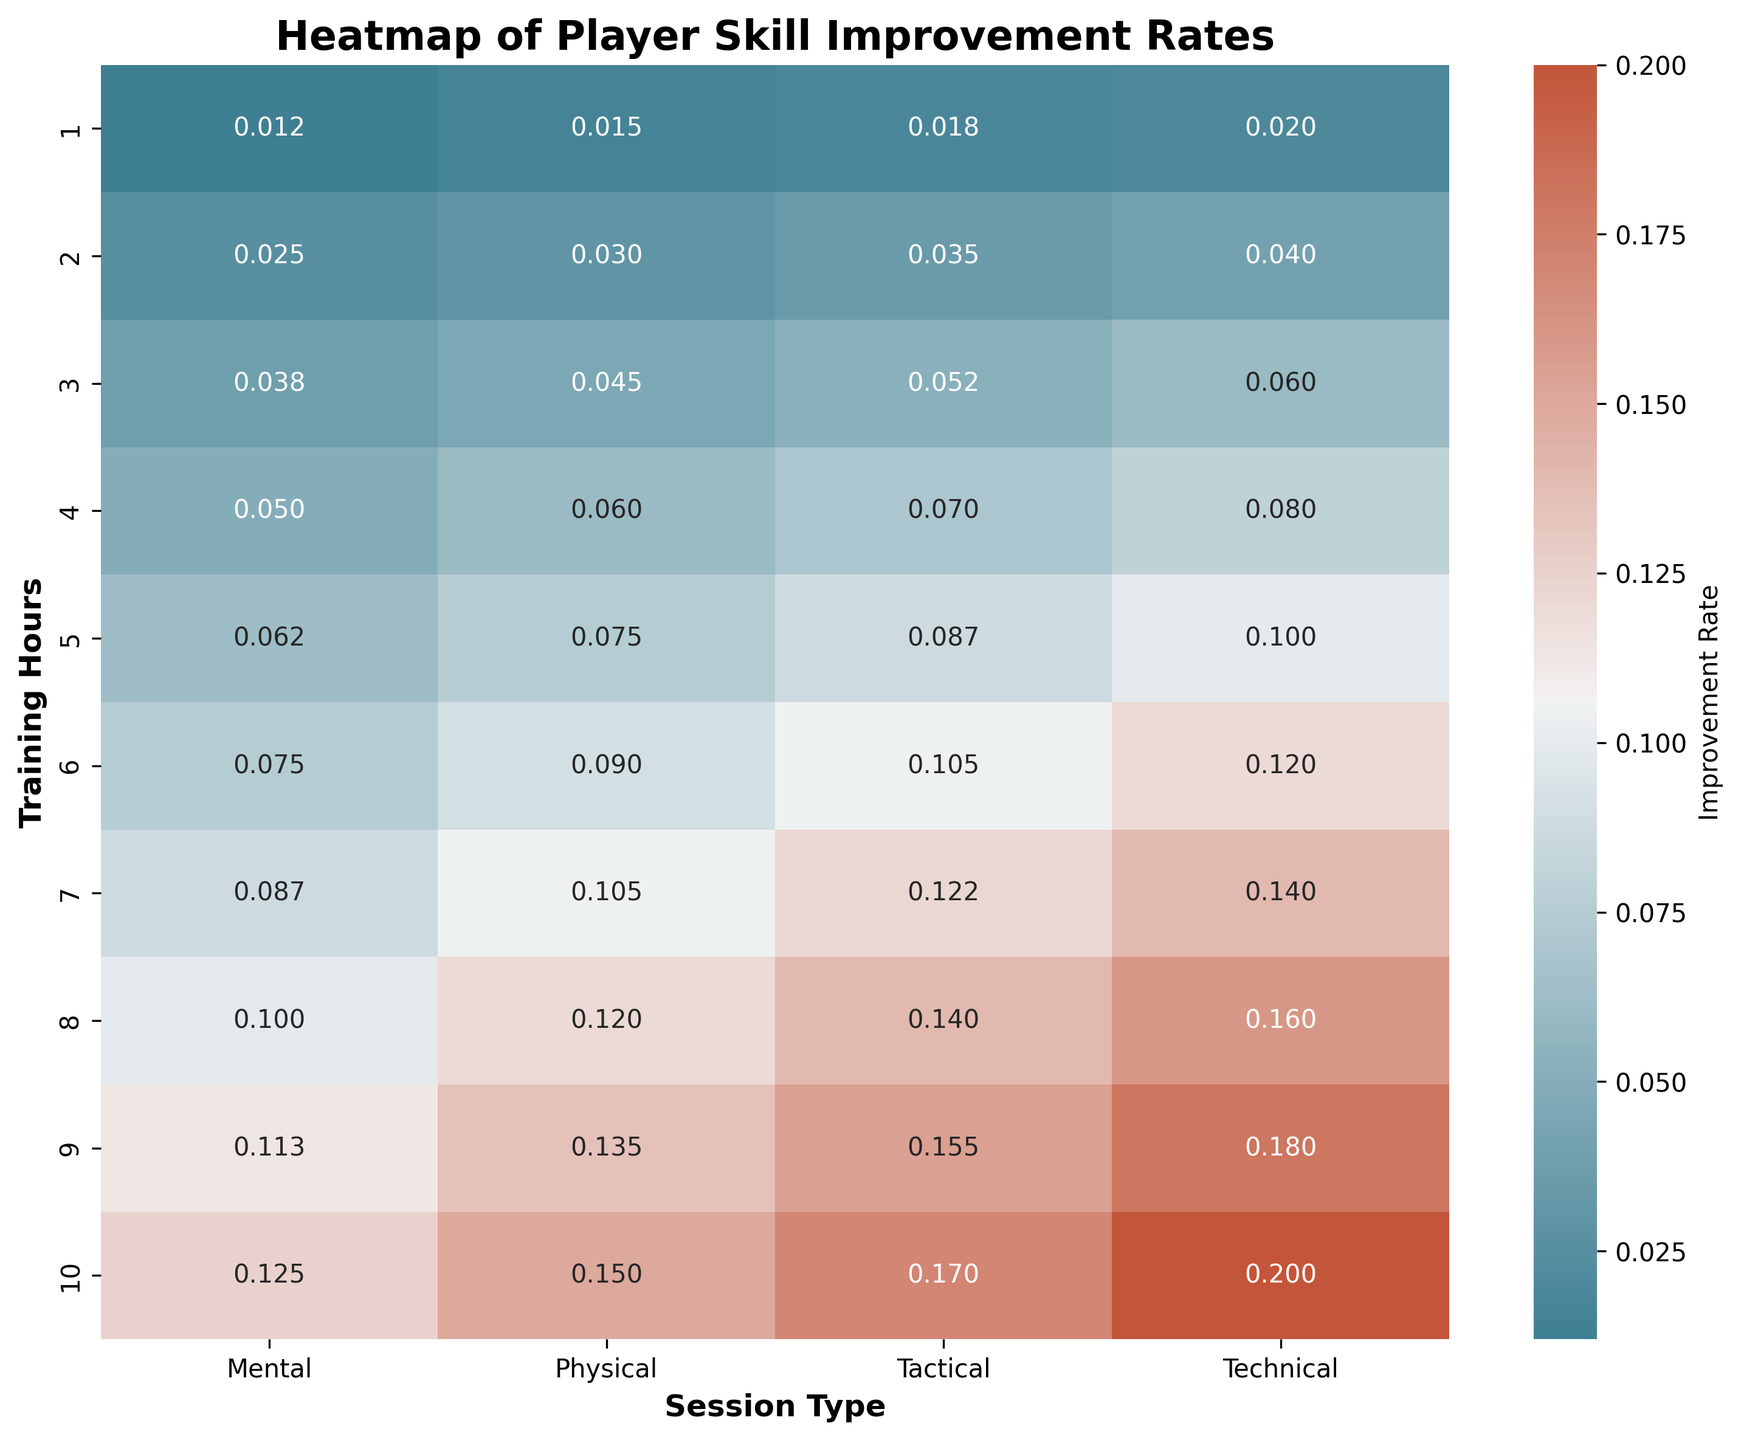what is the improvement rate of 5 hours of mental training Look at the intersection of "5" under "Training Hours" and "Mental" under "Session Type" to find the value
Answer: 0.062 Which session type shows the highest improvement rate for 7 hours of training Find the highest value in the row corresponding to "7" under "Training Hours" and note the corresponding "Session Type"
Answer: Technical By how much does the improvement rate increase from 2 to 4 hours of technical training Find the values at "2" and "4" under "Training Hours" for "Technical," then subtract the former from the latter (0.08 - 0.04)
Answer: 0.04 Does tactical training for 3 hours result in a higher improvement rate than technical training for 2 hours Compare the values for "3" under "Training Hours" for "Tactical" and "2" under "Training Hours" for "Technical"
Answer: Yes Find the average improvement rate across all types of sessions for 6 hours of training Find the values for "6" under "Training Hours" for all "Session Type," sum them and then divide by the number of sessions ((0.12 + 0.09 + 0.105 + 0.075)/4)
Answer: 0.09875 Which session type has the least improvement rate at 10 hours of training Find the smallest value in the row corresponding to "10" under "Training Hours" and note the corresponding "Session Type"
Answer: Mental Are improvements from technical training always higher than from physical training across all training hours Compare all values in "Technical" with corresponding values in "Physical" under "Session Type" for each "Training Hours"
Answer: Yes What is the difference in improvement rates between mental and physical training for 8 hours of training Find the values for "8" under "Training Hours" for "Mental" and "Physical" and subtract one from the other (0.1 - 0.12)
Answer: -0.02 How does the color intensity vary for technical training as training hours increase Note the change in color shade from light to darker as you move down the "Technical" column from top to bottom in the heatmap
Answer: Darker with increasing hours Which session type shows the most consistent improvement rate increase per hour of training Compare the incremental changes for each "Session Type" and see which has the least variance across hours
Answer: Technical 